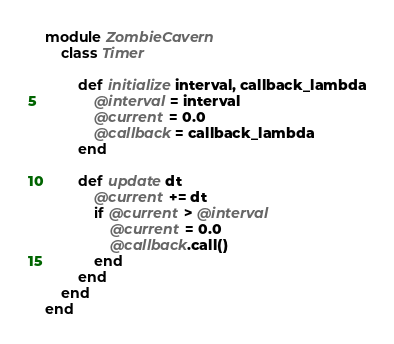<code> <loc_0><loc_0><loc_500><loc_500><_Ruby_>module ZombieCavern
	class Timer

		def initialize interval, callback_lambda
			@interval = interval
			@current = 0.0
			@callback = callback_lambda
		end

		def update dt
			@current += dt
			if @current > @interval
				@current = 0.0
				@callback.call()
			end
		end
	end
end</code> 